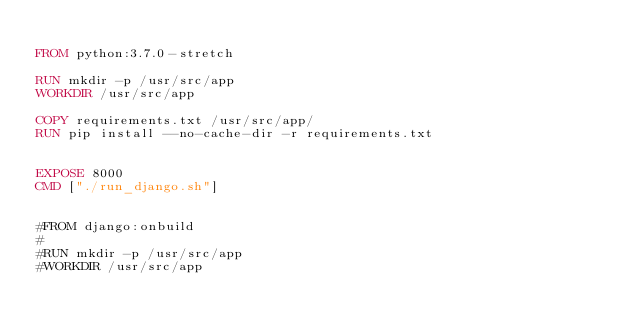<code> <loc_0><loc_0><loc_500><loc_500><_Dockerfile_>
FROM python:3.7.0-stretch

RUN mkdir -p /usr/src/app
WORKDIR /usr/src/app

COPY requirements.txt /usr/src/app/
RUN pip install --no-cache-dir -r requirements.txt


EXPOSE 8000
CMD ["./run_django.sh"]


#FROM django:onbuild
#
#RUN mkdir -p /usr/src/app
#WORKDIR /usr/src/app</code> 